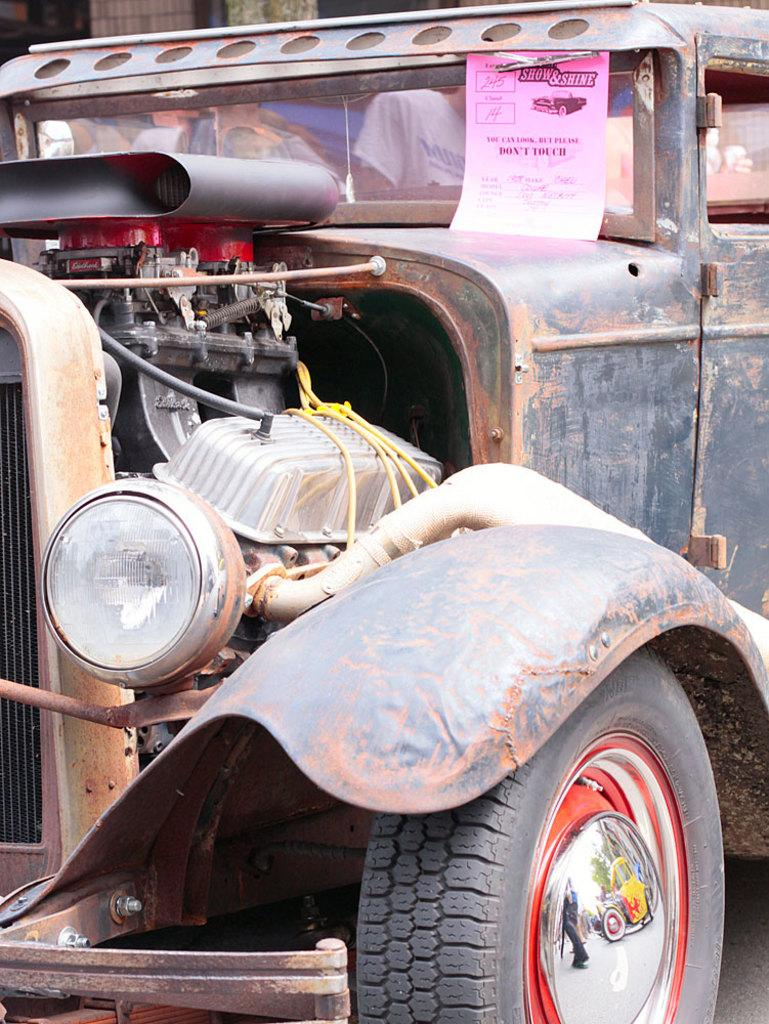What is the main subject of the image? The main subject of the image is a vehicle. What features can be seen on the vehicle? The vehicle has headlamps and tires. Are there any passengers in the vehicle? Yes, there are people sitting in the vehicle. What type of shoe is visible on the dashboard of the vehicle in the image? There is no shoe visible on the dashboard of the vehicle in the image. How does the fan help to cool down the people sitting in the vehicle? There is no fan present in the image; it only shows a vehicle with people sitting inside. 